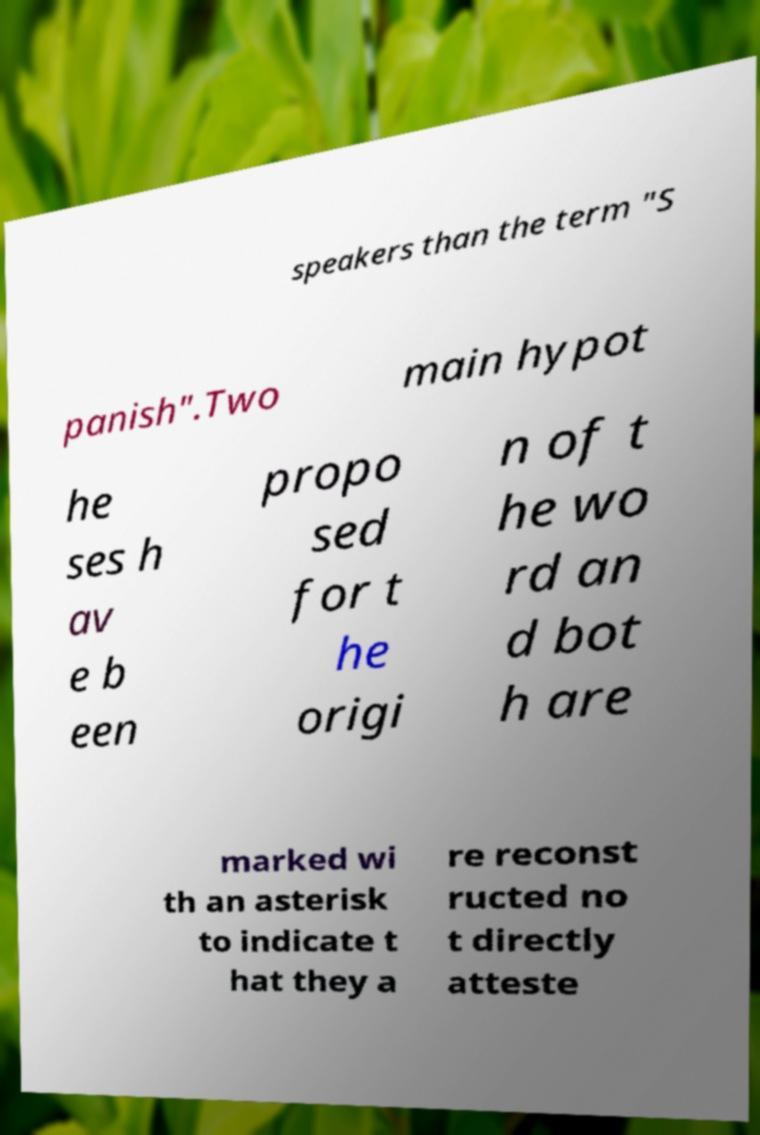What messages or text are displayed in this image? I need them in a readable, typed format. speakers than the term "S panish".Two main hypot he ses h av e b een propo sed for t he origi n of t he wo rd an d bot h are marked wi th an asterisk to indicate t hat they a re reconst ructed no t directly atteste 